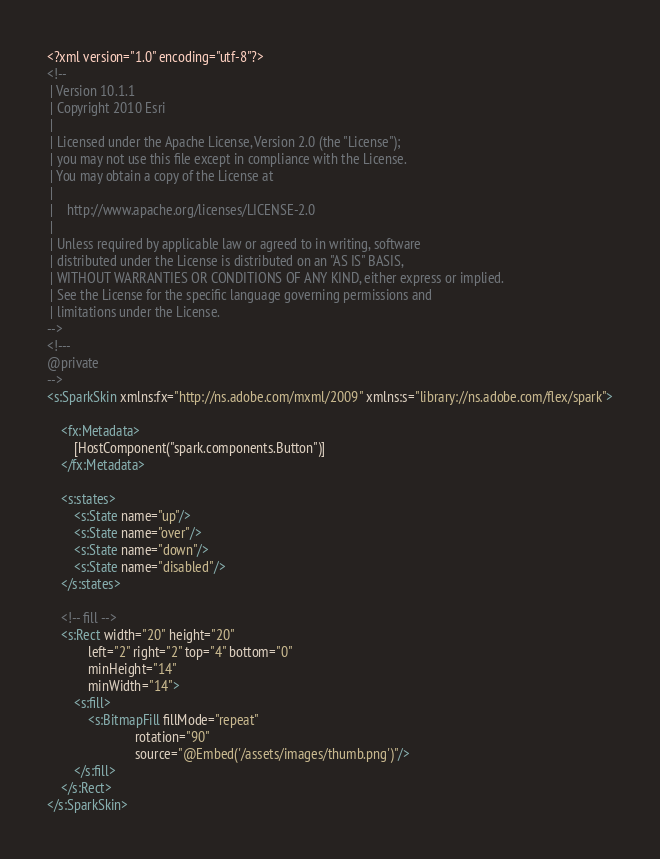<code> <loc_0><loc_0><loc_500><loc_500><_XML_><?xml version="1.0" encoding="utf-8"?>
<!--
 | Version 10.1.1
 | Copyright 2010 Esri
 |
 | Licensed under the Apache License, Version 2.0 (the "License");
 | you may not use this file except in compliance with the License.
 | You may obtain a copy of the License at
 |
 |    http://www.apache.org/licenses/LICENSE-2.0
 |
 | Unless required by applicable law or agreed to in writing, software
 | distributed under the License is distributed on an "AS IS" BASIS,
 | WITHOUT WARRANTIES OR CONDITIONS OF ANY KIND, either express or implied.
 | See the License for the specific language governing permissions and
 | limitations under the License.
-->
<!---
@private
-->
<s:SparkSkin xmlns:fx="http://ns.adobe.com/mxml/2009" xmlns:s="library://ns.adobe.com/flex/spark">

    <fx:Metadata>
        [HostComponent("spark.components.Button")]
    </fx:Metadata>

    <s:states>
        <s:State name="up"/>
        <s:State name="over"/>
        <s:State name="down"/>
        <s:State name="disabled"/>
    </s:states>

    <!-- fill -->
    <s:Rect width="20" height="20"
            left="2" right="2" top="4" bottom="0"
            minHeight="14"
            minWidth="14">
        <s:fill>
            <s:BitmapFill fillMode="repeat"
                          rotation="90"
                          source="@Embed('/assets/images/thumb.png')"/>
        </s:fill>
    </s:Rect>
</s:SparkSkin>
</code> 